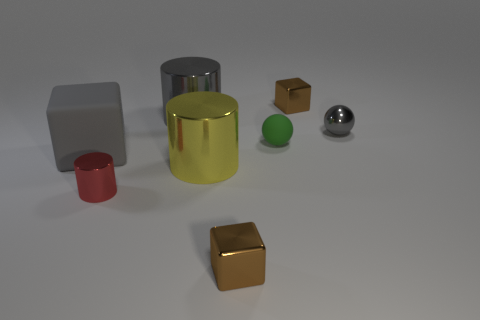Add 1 big red spheres. How many objects exist? 9 Subtract all balls. How many objects are left? 6 Subtract 0 red spheres. How many objects are left? 8 Subtract all large green shiny objects. Subtract all cylinders. How many objects are left? 5 Add 6 gray blocks. How many gray blocks are left? 7 Add 3 small matte objects. How many small matte objects exist? 4 